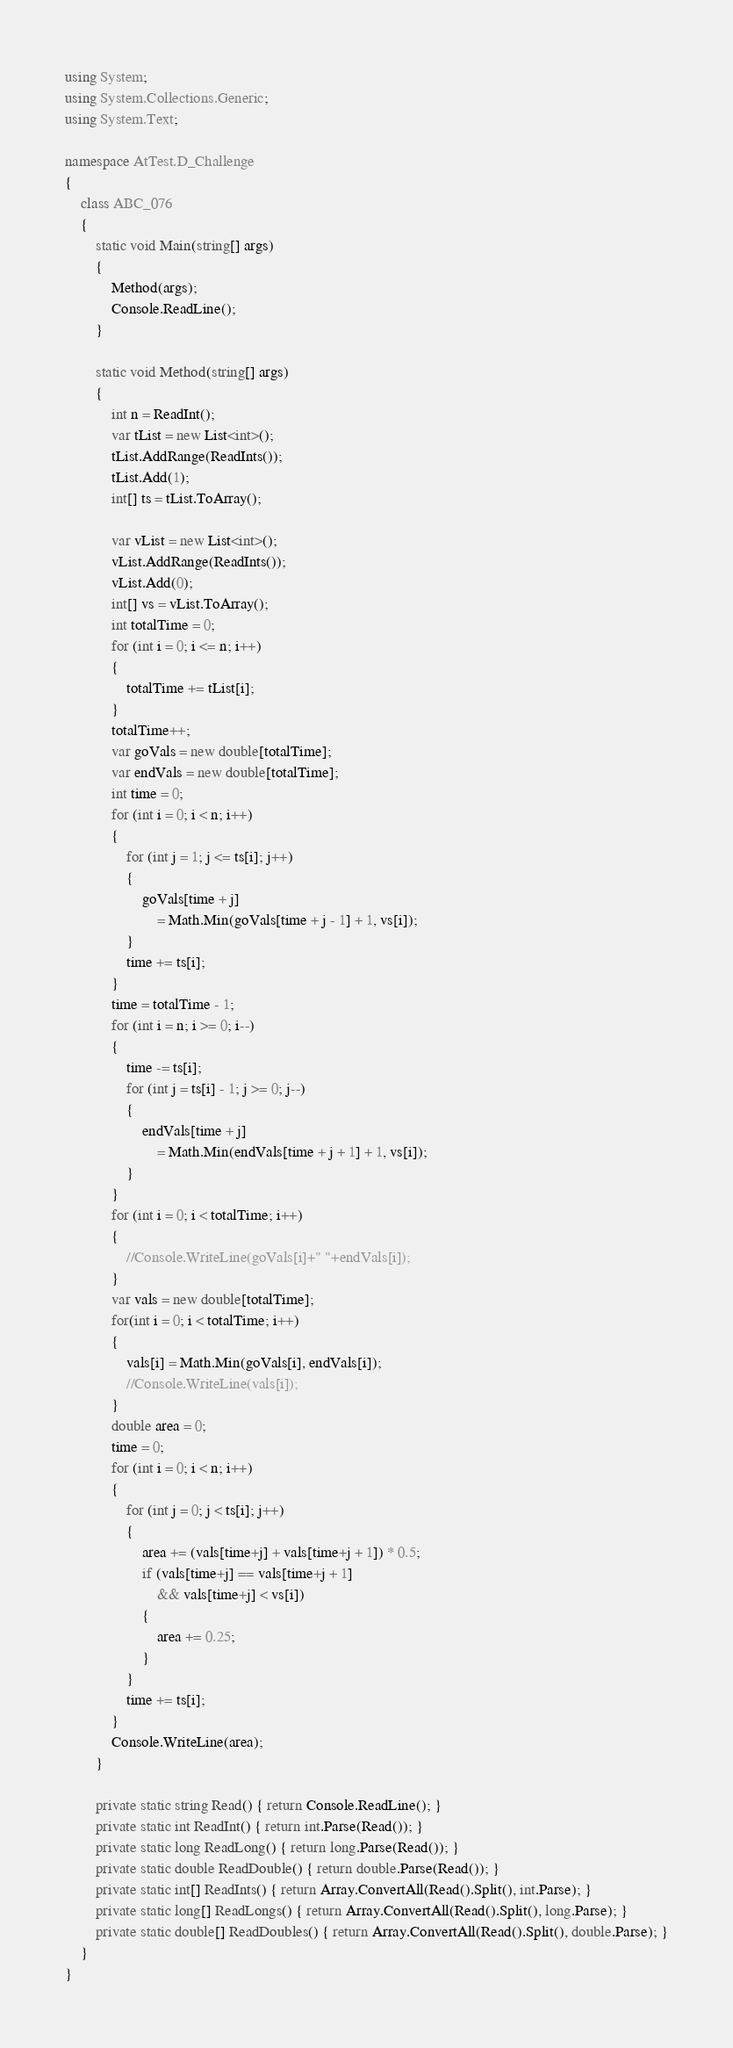<code> <loc_0><loc_0><loc_500><loc_500><_C#_>using System;
using System.Collections.Generic;
using System.Text;

namespace AtTest.D_Challenge
{
    class ABC_076
    {
        static void Main(string[] args)
        {
            Method(args);
            Console.ReadLine();
        }

        static void Method(string[] args)
        {
            int n = ReadInt();
            var tList = new List<int>();
            tList.AddRange(ReadInts());
            tList.Add(1);
            int[] ts = tList.ToArray();

            var vList = new List<int>();
            vList.AddRange(ReadInts());
            vList.Add(0);
            int[] vs = vList.ToArray();
            int totalTime = 0;
            for (int i = 0; i <= n; i++)
            {
                totalTime += tList[i];
            }
            totalTime++;
            var goVals = new double[totalTime];
            var endVals = new double[totalTime];
            int time = 0;
            for (int i = 0; i < n; i++)
            {
                for (int j = 1; j <= ts[i]; j++)
                {
                    goVals[time + j]
                        = Math.Min(goVals[time + j - 1] + 1, vs[i]);
                }
                time += ts[i];
            }
            time = totalTime - 1;
            for (int i = n; i >= 0; i--)
            {
                time -= ts[i];
                for (int j = ts[i] - 1; j >= 0; j--)
                {
                    endVals[time + j]
                        = Math.Min(endVals[time + j + 1] + 1, vs[i]);
                }
            }
            for (int i = 0; i < totalTime; i++)
            {
                //Console.WriteLine(goVals[i]+" "+endVals[i]);
            }
            var vals = new double[totalTime];
            for(int i = 0; i < totalTime; i++)
            {
                vals[i] = Math.Min(goVals[i], endVals[i]);
                //Console.WriteLine(vals[i]);
            }
            double area = 0;
            time = 0;
            for (int i = 0; i < n; i++)
            {
                for (int j = 0; j < ts[i]; j++)
                {
                    area += (vals[time+j] + vals[time+j + 1]) * 0.5;
                    if (vals[time+j] == vals[time+j + 1]
                        && vals[time+j] < vs[i])
                    {
                        area += 0.25;
                    }
                }
                time += ts[i];
            }
            Console.WriteLine(area);
        }

        private static string Read() { return Console.ReadLine(); }
        private static int ReadInt() { return int.Parse(Read()); }
        private static long ReadLong() { return long.Parse(Read()); }
        private static double ReadDouble() { return double.Parse(Read()); }
        private static int[] ReadInts() { return Array.ConvertAll(Read().Split(), int.Parse); }
        private static long[] ReadLongs() { return Array.ConvertAll(Read().Split(), long.Parse); }
        private static double[] ReadDoubles() { return Array.ConvertAll(Read().Split(), double.Parse); }
    }
}
</code> 